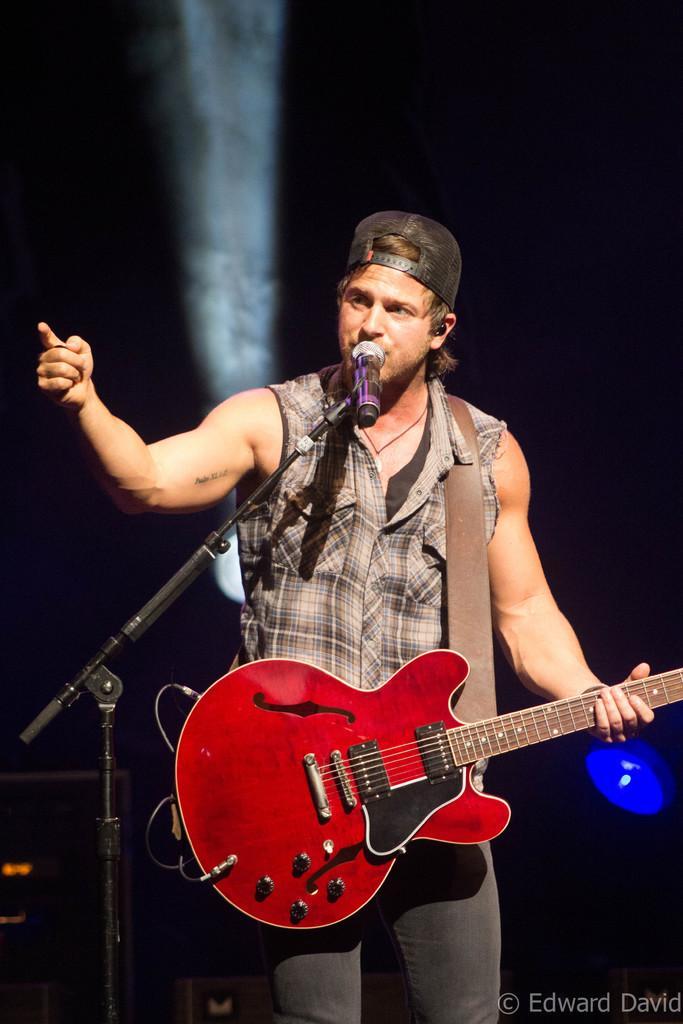Please provide a concise description of this image. The person wearing cap is standing and holding a guitar in his hand and singing in front of a mic. 